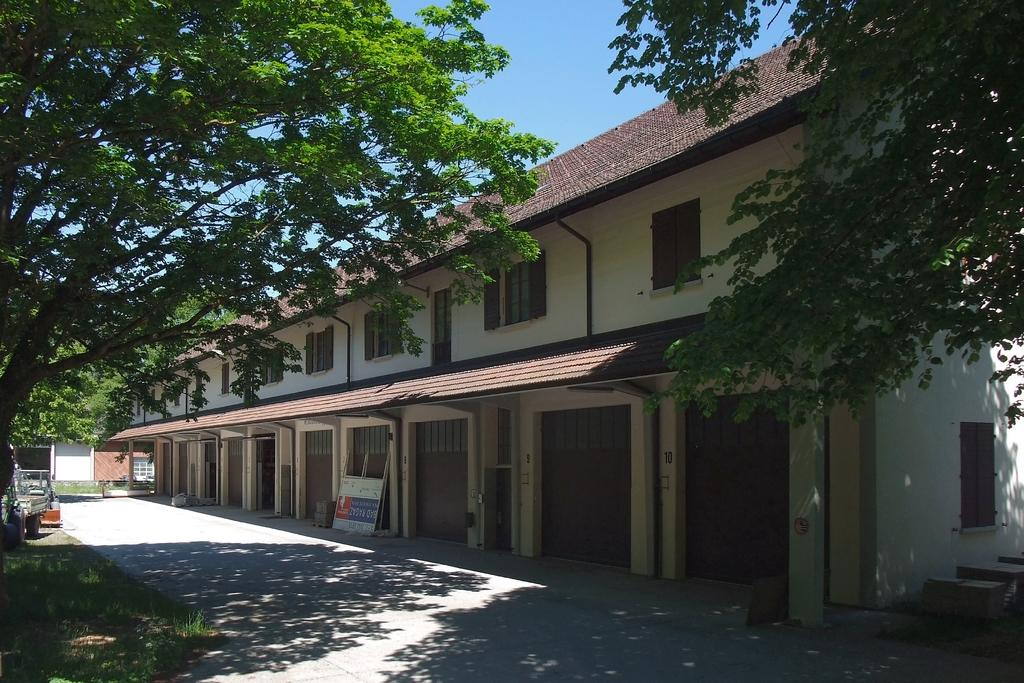What type of structures can be seen in the image? There are buildings in the image. What natural elements are present in the image? There are trees and grass in the image. What objects can be seen in the image? There are boards in the image. What type of cheese is being delivered in the parcel shown in the image? There is no parcel or cheese present in the image. What is the minister doing in the image? There is no minister present in the image. 